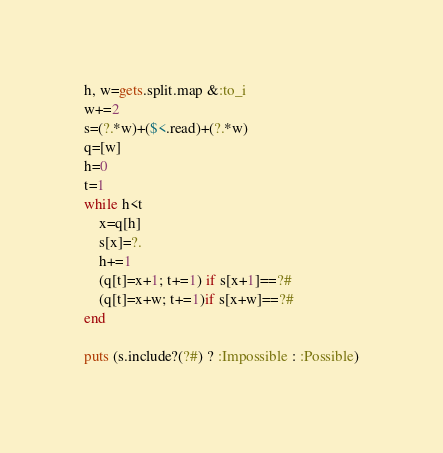<code> <loc_0><loc_0><loc_500><loc_500><_Ruby_>h, w=gets.split.map &:to_i
w+=2
s=(?.*w)+($<.read)+(?.*w)
q=[w]
h=0
t=1
while h<t
    x=q[h]
    s[x]=?.
    h+=1
    (q[t]=x+1; t+=1) if s[x+1]==?#
    (q[t]=x+w; t+=1)if s[x+w]==?#
end

puts (s.include?(?#) ? :Impossible : :Possible)
</code> 